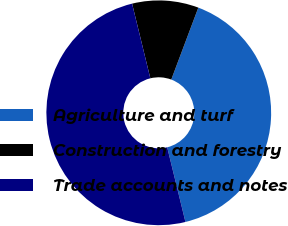Convert chart to OTSL. <chart><loc_0><loc_0><loc_500><loc_500><pie_chart><fcel>Agriculture and turf<fcel>Construction and forestry<fcel>Trade accounts and notes<nl><fcel>40.46%<fcel>9.54%<fcel>50.0%<nl></chart> 